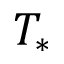Convert formula to latex. <formula><loc_0><loc_0><loc_500><loc_500>T _ { * }</formula> 